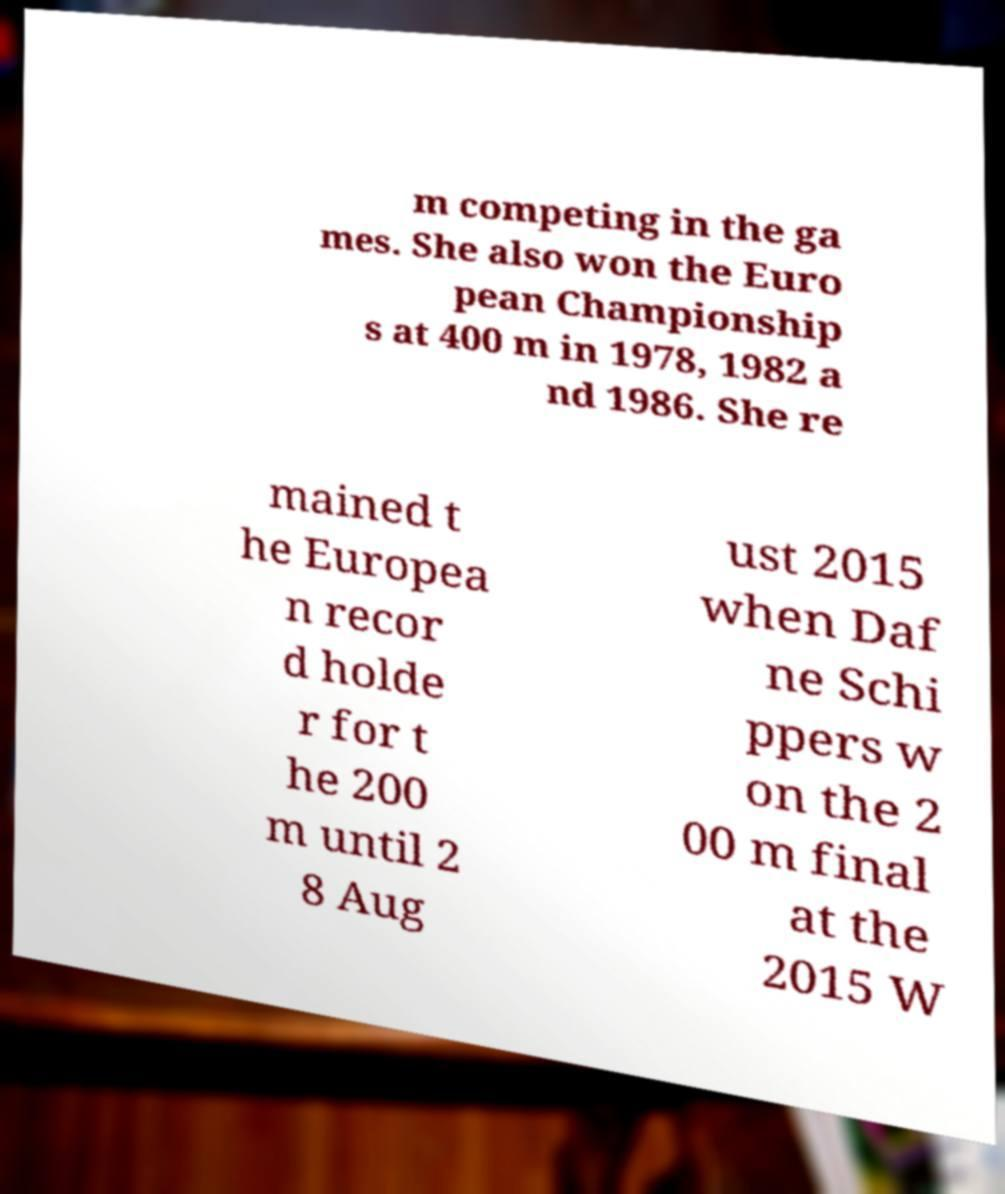Please read and relay the text visible in this image. What does it say? m competing in the ga mes. She also won the Euro pean Championship s at 400 m in 1978, 1982 a nd 1986. She re mained t he Europea n recor d holde r for t he 200 m until 2 8 Aug ust 2015 when Daf ne Schi ppers w on the 2 00 m final at the 2015 W 